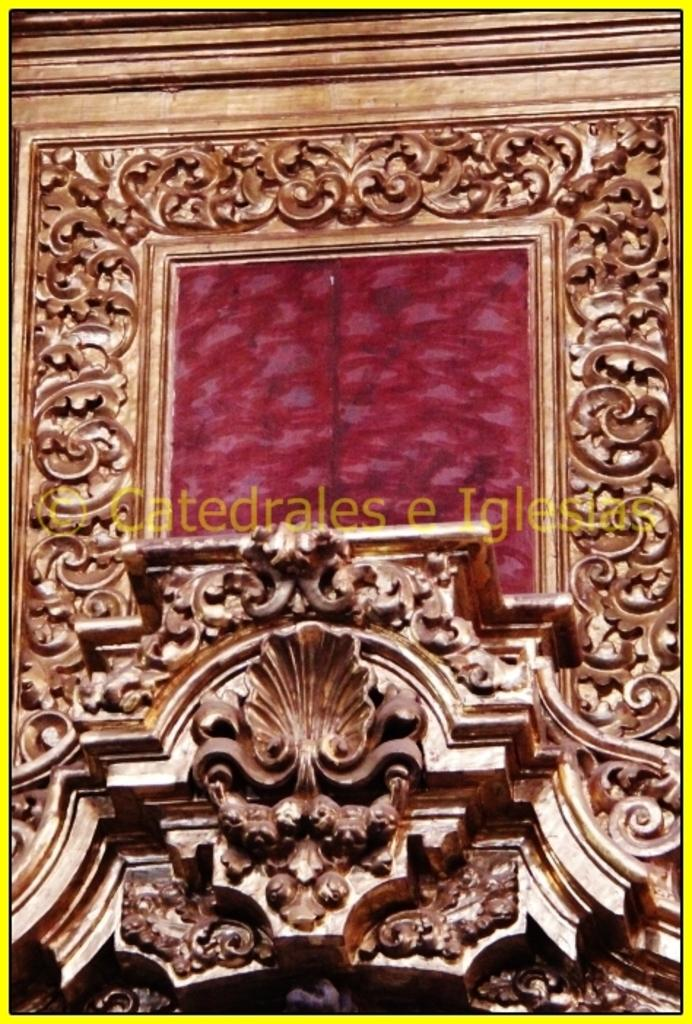What can be seen on the door in the image? There are carvings on a door in the image. What is located in the center of the image? There is some text in the center of the image. How many pigs are depicted in the carvings on the door in the image? There is no mention of pigs in the image; the carvings on the door are not described in detail. What type of detail can be seen in the carvings on the door in the image? The provided facts do not describe the specific details of the carvings on the door. 